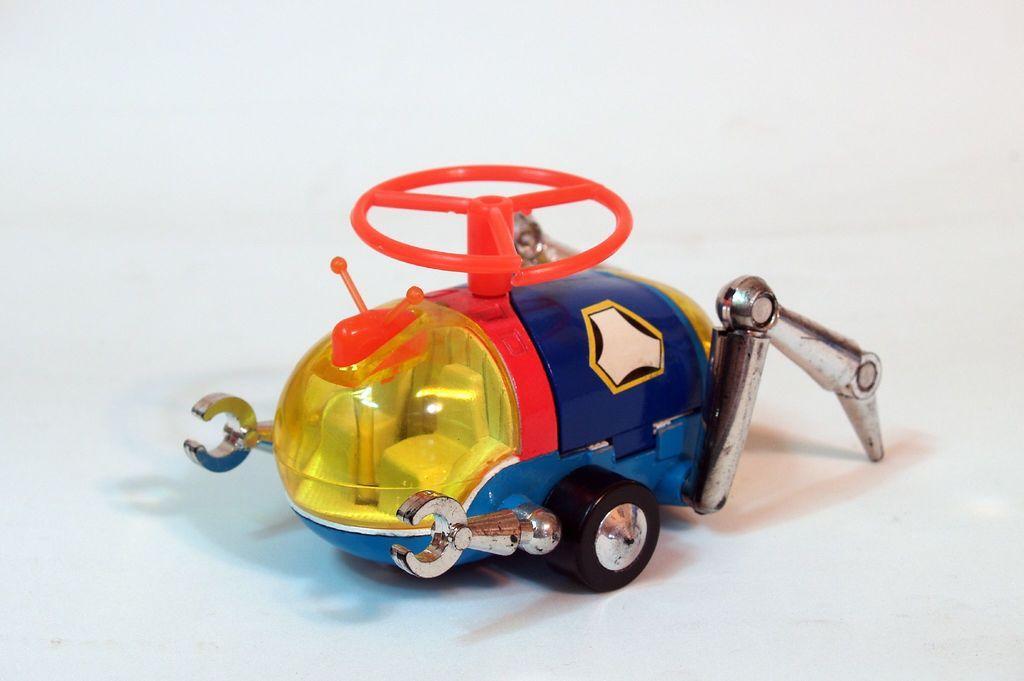Please provide a concise description of this image. In this picture we can see a toy in the middle of the image. 